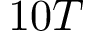Convert formula to latex. <formula><loc_0><loc_0><loc_500><loc_500>1 0 T</formula> 